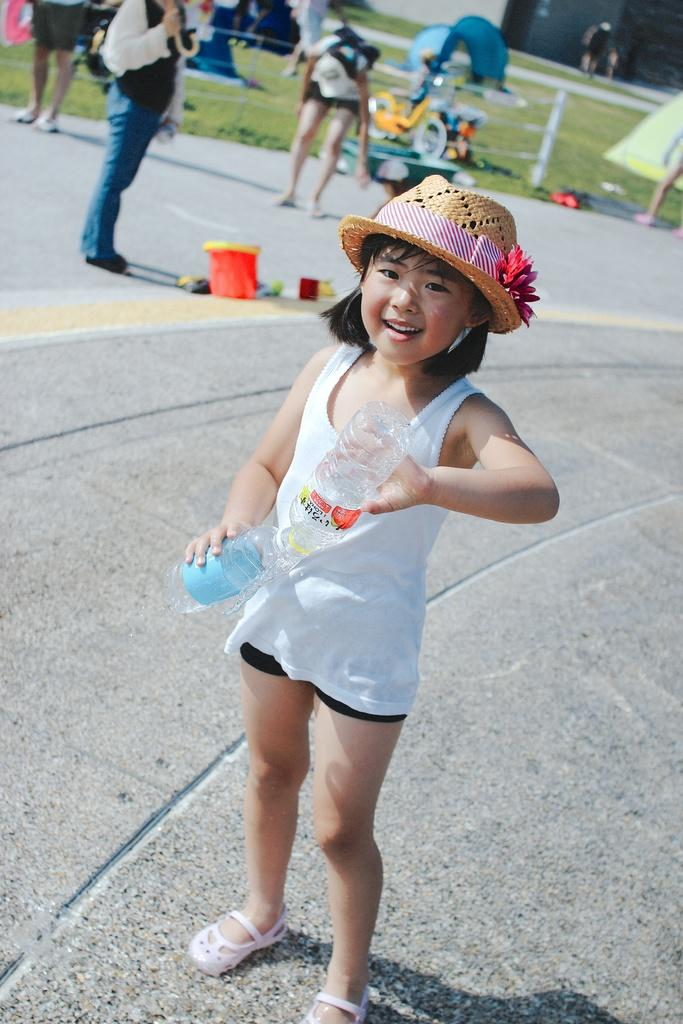What is the main subject of the image? The main subject of the image is a kid standing. What is the kid holding in the image? The kid is holding bottles in the image. Can you describe the people behind the kid? There are people behind the kid in the image. What can be found on the ground in the image? There are objects on the ground in the image. What type of shelter is visible in the image? There are tents in the image. What kind of barrier is present in the image? There is a fence in the image. How many turkeys can be seen interacting with the boys in the image? There are no turkeys or boys present in the image. What specific detail can be seen on the kid's clothing in the image? The provided facts do not mention any specific details about the kid's clothing. 